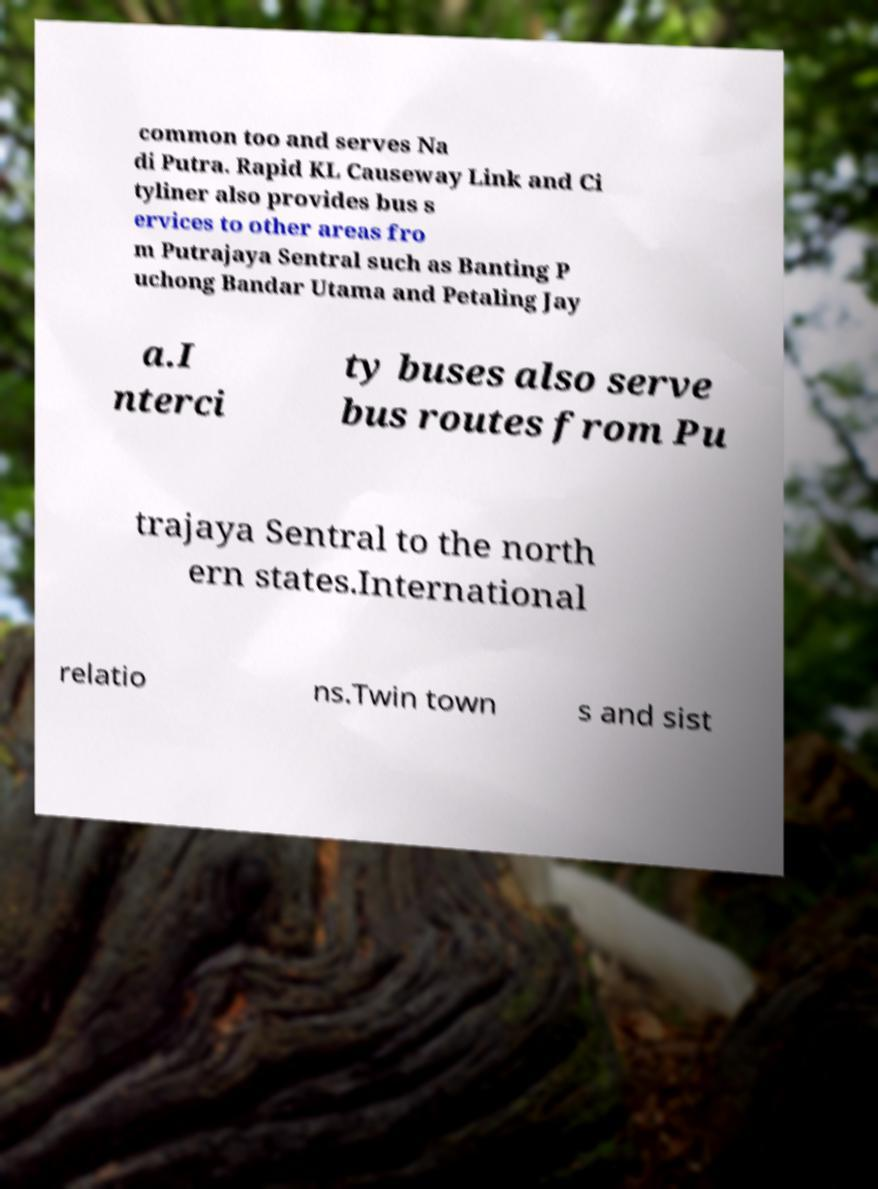For documentation purposes, I need the text within this image transcribed. Could you provide that? common too and serves Na di Putra. Rapid KL Causeway Link and Ci tyliner also provides bus s ervices to other areas fro m Putrajaya Sentral such as Banting P uchong Bandar Utama and Petaling Jay a.I nterci ty buses also serve bus routes from Pu trajaya Sentral to the north ern states.International relatio ns.Twin town s and sist 